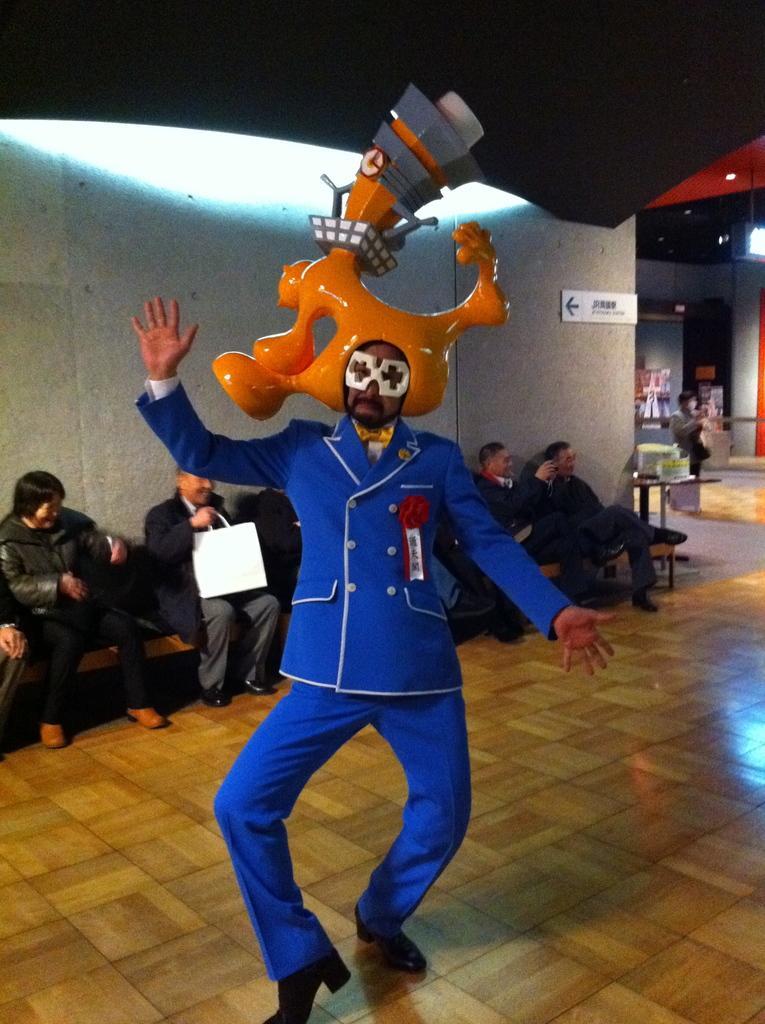How would you summarize this image in a sentence or two? There is a man in motion and wore costume and there are people sitting on bench and this man holding a bag. We can see board on a wall. In the background we can see objects on the table, person, lights and few objects. 